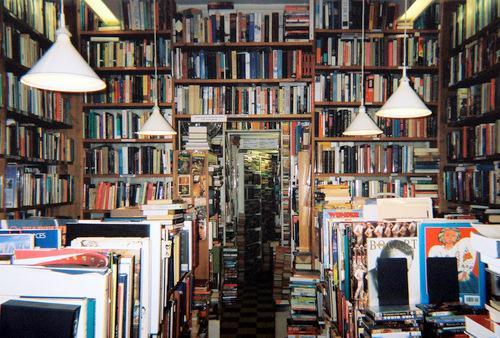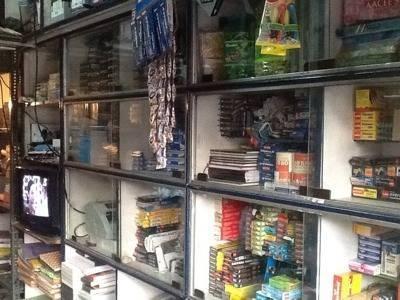The first image is the image on the left, the second image is the image on the right. Evaluate the accuracy of this statement regarding the images: "One of the images is of writing supplies, hanging on a wall.". Is it true? Answer yes or no. No. The first image is the image on the left, the second image is the image on the right. For the images displayed, is the sentence "Black wires can be seen in one of the images." factually correct? Answer yes or no. Yes. 